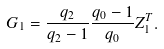Convert formula to latex. <formula><loc_0><loc_0><loc_500><loc_500>G _ { 1 } = \frac { q _ { 2 } } { q _ { 2 } - 1 } \frac { q _ { 0 } - 1 } { q _ { 0 } } Z ^ { T } _ { 1 } .</formula> 